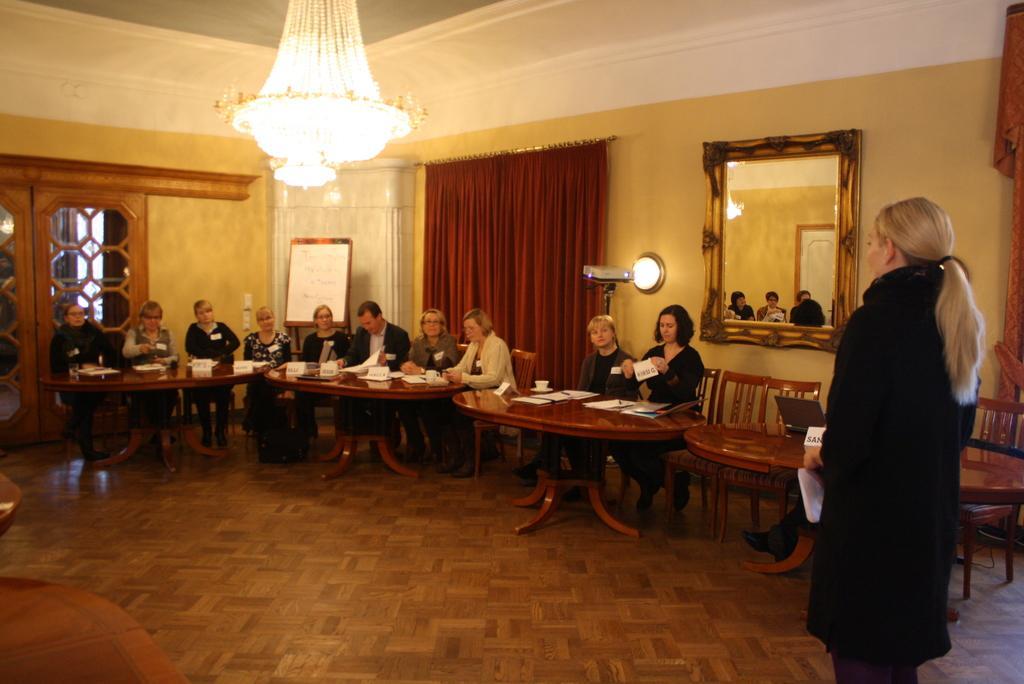Describe this image in one or two sentences. In this image i can see group of people sitting on chairs in front of few tables. To the left of the image i can see a door. In the background i can see the wall, a chandelier, a board, a curtain and the mirror. To the right side of the image i can see a woman standing. 